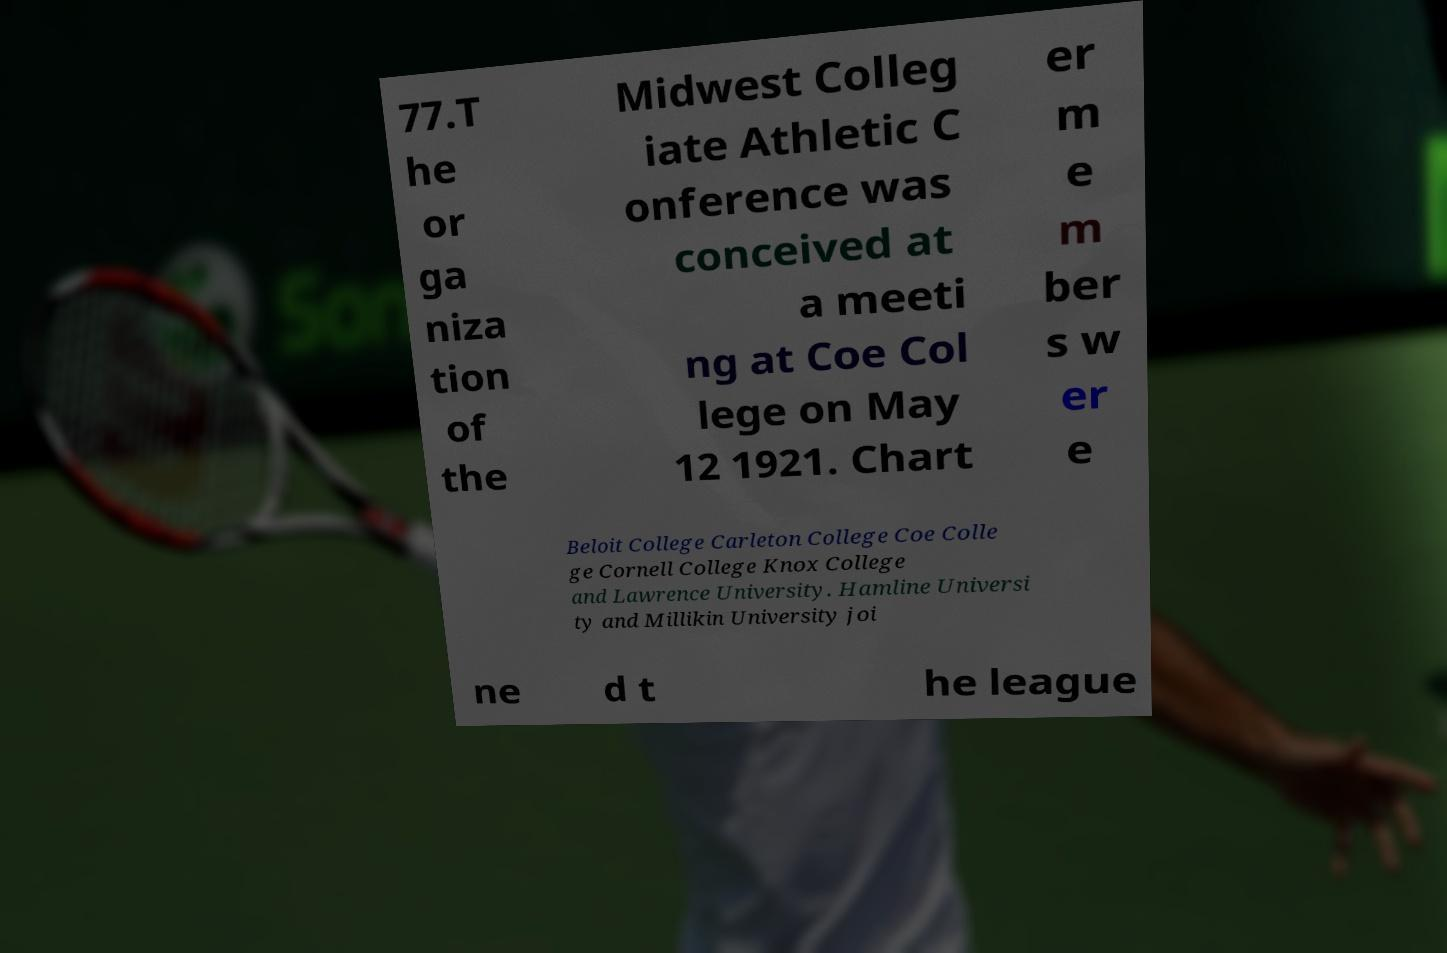Could you extract and type out the text from this image? 77.T he or ga niza tion of the Midwest Colleg iate Athletic C onference was conceived at a meeti ng at Coe Col lege on May 12 1921. Chart er m e m ber s w er e Beloit College Carleton College Coe Colle ge Cornell College Knox College and Lawrence University. Hamline Universi ty and Millikin University joi ne d t he league 